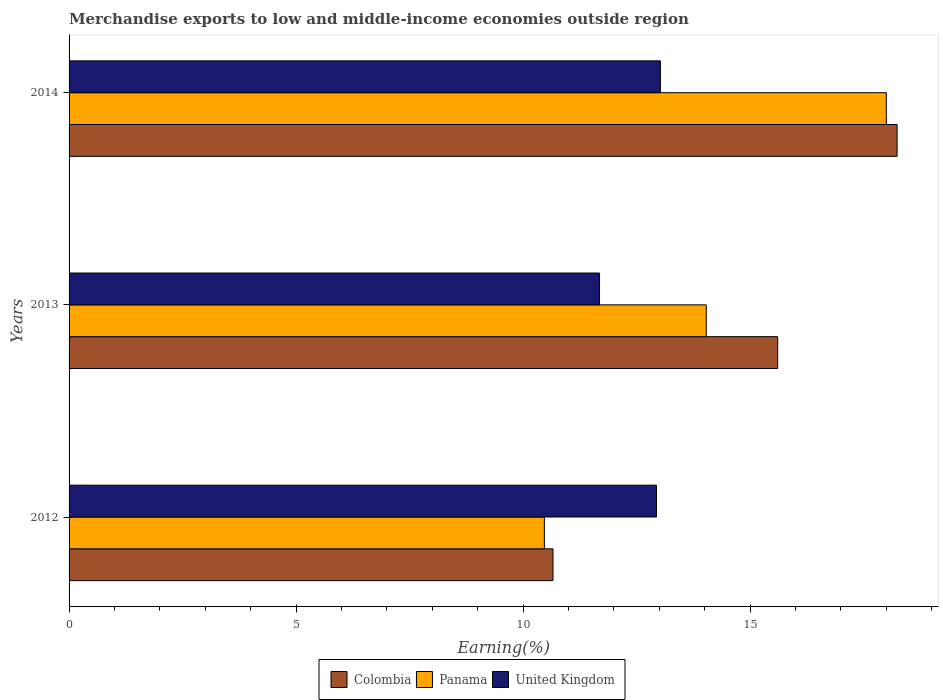How many different coloured bars are there?
Provide a short and direct response. 3. Are the number of bars per tick equal to the number of legend labels?
Give a very brief answer. Yes. Are the number of bars on each tick of the Y-axis equal?
Keep it short and to the point. Yes. How many bars are there on the 1st tick from the bottom?
Your answer should be very brief. 3. What is the label of the 1st group of bars from the top?
Your response must be concise. 2014. In how many cases, is the number of bars for a given year not equal to the number of legend labels?
Provide a short and direct response. 0. What is the percentage of amount earned from merchandise exports in United Kingdom in 2013?
Provide a succinct answer. 11.68. Across all years, what is the maximum percentage of amount earned from merchandise exports in United Kingdom?
Make the answer very short. 13.03. Across all years, what is the minimum percentage of amount earned from merchandise exports in United Kingdom?
Provide a succinct answer. 11.68. In which year was the percentage of amount earned from merchandise exports in United Kingdom maximum?
Offer a very short reply. 2014. What is the total percentage of amount earned from merchandise exports in Panama in the graph?
Provide a short and direct response. 42.51. What is the difference between the percentage of amount earned from merchandise exports in Colombia in 2012 and that in 2013?
Provide a short and direct response. -4.95. What is the difference between the percentage of amount earned from merchandise exports in Panama in 2014 and the percentage of amount earned from merchandise exports in Colombia in 2013?
Offer a very short reply. 2.39. What is the average percentage of amount earned from merchandise exports in United Kingdom per year?
Offer a very short reply. 12.55. In the year 2012, what is the difference between the percentage of amount earned from merchandise exports in Panama and percentage of amount earned from merchandise exports in United Kingdom?
Make the answer very short. -2.47. What is the ratio of the percentage of amount earned from merchandise exports in Panama in 2012 to that in 2014?
Your response must be concise. 0.58. Is the difference between the percentage of amount earned from merchandise exports in Panama in 2012 and 2014 greater than the difference between the percentage of amount earned from merchandise exports in United Kingdom in 2012 and 2014?
Ensure brevity in your answer.  No. What is the difference between the highest and the second highest percentage of amount earned from merchandise exports in Colombia?
Your response must be concise. 2.63. What is the difference between the highest and the lowest percentage of amount earned from merchandise exports in United Kingdom?
Keep it short and to the point. 1.34. In how many years, is the percentage of amount earned from merchandise exports in Panama greater than the average percentage of amount earned from merchandise exports in Panama taken over all years?
Your answer should be compact. 1. What does the 1st bar from the bottom in 2013 represents?
Make the answer very short. Colombia. Is it the case that in every year, the sum of the percentage of amount earned from merchandise exports in United Kingdom and percentage of amount earned from merchandise exports in Colombia is greater than the percentage of amount earned from merchandise exports in Panama?
Your response must be concise. Yes. How many bars are there?
Make the answer very short. 9. Are all the bars in the graph horizontal?
Give a very brief answer. Yes. What is the difference between two consecutive major ticks on the X-axis?
Your answer should be very brief. 5. Are the values on the major ticks of X-axis written in scientific E-notation?
Provide a short and direct response. No. Does the graph contain any zero values?
Your answer should be compact. No. How many legend labels are there?
Offer a terse response. 3. What is the title of the graph?
Your answer should be compact. Merchandise exports to low and middle-income economies outside region. Does "Iraq" appear as one of the legend labels in the graph?
Provide a succinct answer. No. What is the label or title of the X-axis?
Ensure brevity in your answer.  Earning(%). What is the label or title of the Y-axis?
Provide a succinct answer. Years. What is the Earning(%) of Colombia in 2012?
Keep it short and to the point. 10.66. What is the Earning(%) of Panama in 2012?
Make the answer very short. 10.47. What is the Earning(%) of United Kingdom in 2012?
Offer a terse response. 12.94. What is the Earning(%) in Colombia in 2013?
Provide a succinct answer. 15.61. What is the Earning(%) of Panama in 2013?
Keep it short and to the point. 14.04. What is the Earning(%) in United Kingdom in 2013?
Offer a terse response. 11.68. What is the Earning(%) in Colombia in 2014?
Give a very brief answer. 18.24. What is the Earning(%) in Panama in 2014?
Offer a very short reply. 18. What is the Earning(%) in United Kingdom in 2014?
Provide a short and direct response. 13.03. Across all years, what is the maximum Earning(%) in Colombia?
Your response must be concise. 18.24. Across all years, what is the maximum Earning(%) of Panama?
Keep it short and to the point. 18. Across all years, what is the maximum Earning(%) of United Kingdom?
Ensure brevity in your answer.  13.03. Across all years, what is the minimum Earning(%) in Colombia?
Give a very brief answer. 10.66. Across all years, what is the minimum Earning(%) of Panama?
Your response must be concise. 10.47. Across all years, what is the minimum Earning(%) in United Kingdom?
Your answer should be very brief. 11.68. What is the total Earning(%) in Colombia in the graph?
Your answer should be compact. 44.51. What is the total Earning(%) of Panama in the graph?
Your answer should be compact. 42.51. What is the total Earning(%) of United Kingdom in the graph?
Ensure brevity in your answer.  37.65. What is the difference between the Earning(%) in Colombia in 2012 and that in 2013?
Keep it short and to the point. -4.95. What is the difference between the Earning(%) in Panama in 2012 and that in 2013?
Your answer should be very brief. -3.57. What is the difference between the Earning(%) of United Kingdom in 2012 and that in 2013?
Offer a terse response. 1.26. What is the difference between the Earning(%) in Colombia in 2012 and that in 2014?
Ensure brevity in your answer.  -7.58. What is the difference between the Earning(%) of Panama in 2012 and that in 2014?
Keep it short and to the point. -7.53. What is the difference between the Earning(%) of United Kingdom in 2012 and that in 2014?
Offer a terse response. -0.09. What is the difference between the Earning(%) in Colombia in 2013 and that in 2014?
Your answer should be compact. -2.63. What is the difference between the Earning(%) of Panama in 2013 and that in 2014?
Your answer should be compact. -3.97. What is the difference between the Earning(%) in United Kingdom in 2013 and that in 2014?
Give a very brief answer. -1.34. What is the difference between the Earning(%) in Colombia in 2012 and the Earning(%) in Panama in 2013?
Offer a very short reply. -3.38. What is the difference between the Earning(%) of Colombia in 2012 and the Earning(%) of United Kingdom in 2013?
Provide a succinct answer. -1.02. What is the difference between the Earning(%) in Panama in 2012 and the Earning(%) in United Kingdom in 2013?
Provide a short and direct response. -1.22. What is the difference between the Earning(%) of Colombia in 2012 and the Earning(%) of Panama in 2014?
Offer a terse response. -7.34. What is the difference between the Earning(%) of Colombia in 2012 and the Earning(%) of United Kingdom in 2014?
Offer a terse response. -2.37. What is the difference between the Earning(%) in Panama in 2012 and the Earning(%) in United Kingdom in 2014?
Your answer should be compact. -2.56. What is the difference between the Earning(%) in Colombia in 2013 and the Earning(%) in Panama in 2014?
Keep it short and to the point. -2.39. What is the difference between the Earning(%) in Colombia in 2013 and the Earning(%) in United Kingdom in 2014?
Offer a very short reply. 2.58. What is the difference between the Earning(%) in Panama in 2013 and the Earning(%) in United Kingdom in 2014?
Keep it short and to the point. 1.01. What is the average Earning(%) in Colombia per year?
Your response must be concise. 14.84. What is the average Earning(%) of Panama per year?
Your response must be concise. 14.17. What is the average Earning(%) of United Kingdom per year?
Offer a terse response. 12.55. In the year 2012, what is the difference between the Earning(%) of Colombia and Earning(%) of Panama?
Provide a short and direct response. 0.19. In the year 2012, what is the difference between the Earning(%) in Colombia and Earning(%) in United Kingdom?
Ensure brevity in your answer.  -2.28. In the year 2012, what is the difference between the Earning(%) in Panama and Earning(%) in United Kingdom?
Make the answer very short. -2.47. In the year 2013, what is the difference between the Earning(%) in Colombia and Earning(%) in Panama?
Provide a short and direct response. 1.57. In the year 2013, what is the difference between the Earning(%) in Colombia and Earning(%) in United Kingdom?
Keep it short and to the point. 3.93. In the year 2013, what is the difference between the Earning(%) in Panama and Earning(%) in United Kingdom?
Your answer should be very brief. 2.35. In the year 2014, what is the difference between the Earning(%) in Colombia and Earning(%) in Panama?
Offer a terse response. 0.24. In the year 2014, what is the difference between the Earning(%) of Colombia and Earning(%) of United Kingdom?
Offer a terse response. 5.21. In the year 2014, what is the difference between the Earning(%) in Panama and Earning(%) in United Kingdom?
Ensure brevity in your answer.  4.98. What is the ratio of the Earning(%) of Colombia in 2012 to that in 2013?
Offer a terse response. 0.68. What is the ratio of the Earning(%) in Panama in 2012 to that in 2013?
Provide a succinct answer. 0.75. What is the ratio of the Earning(%) in United Kingdom in 2012 to that in 2013?
Keep it short and to the point. 1.11. What is the ratio of the Earning(%) in Colombia in 2012 to that in 2014?
Provide a succinct answer. 0.58. What is the ratio of the Earning(%) of Panama in 2012 to that in 2014?
Give a very brief answer. 0.58. What is the ratio of the Earning(%) of United Kingdom in 2012 to that in 2014?
Keep it short and to the point. 0.99. What is the ratio of the Earning(%) of Colombia in 2013 to that in 2014?
Your response must be concise. 0.86. What is the ratio of the Earning(%) of Panama in 2013 to that in 2014?
Ensure brevity in your answer.  0.78. What is the ratio of the Earning(%) in United Kingdom in 2013 to that in 2014?
Make the answer very short. 0.9. What is the difference between the highest and the second highest Earning(%) of Colombia?
Your response must be concise. 2.63. What is the difference between the highest and the second highest Earning(%) in Panama?
Offer a terse response. 3.97. What is the difference between the highest and the second highest Earning(%) of United Kingdom?
Make the answer very short. 0.09. What is the difference between the highest and the lowest Earning(%) in Colombia?
Keep it short and to the point. 7.58. What is the difference between the highest and the lowest Earning(%) in Panama?
Keep it short and to the point. 7.53. What is the difference between the highest and the lowest Earning(%) of United Kingdom?
Provide a short and direct response. 1.34. 